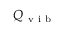<formula> <loc_0><loc_0><loc_500><loc_500>Q _ { v i b }</formula> 